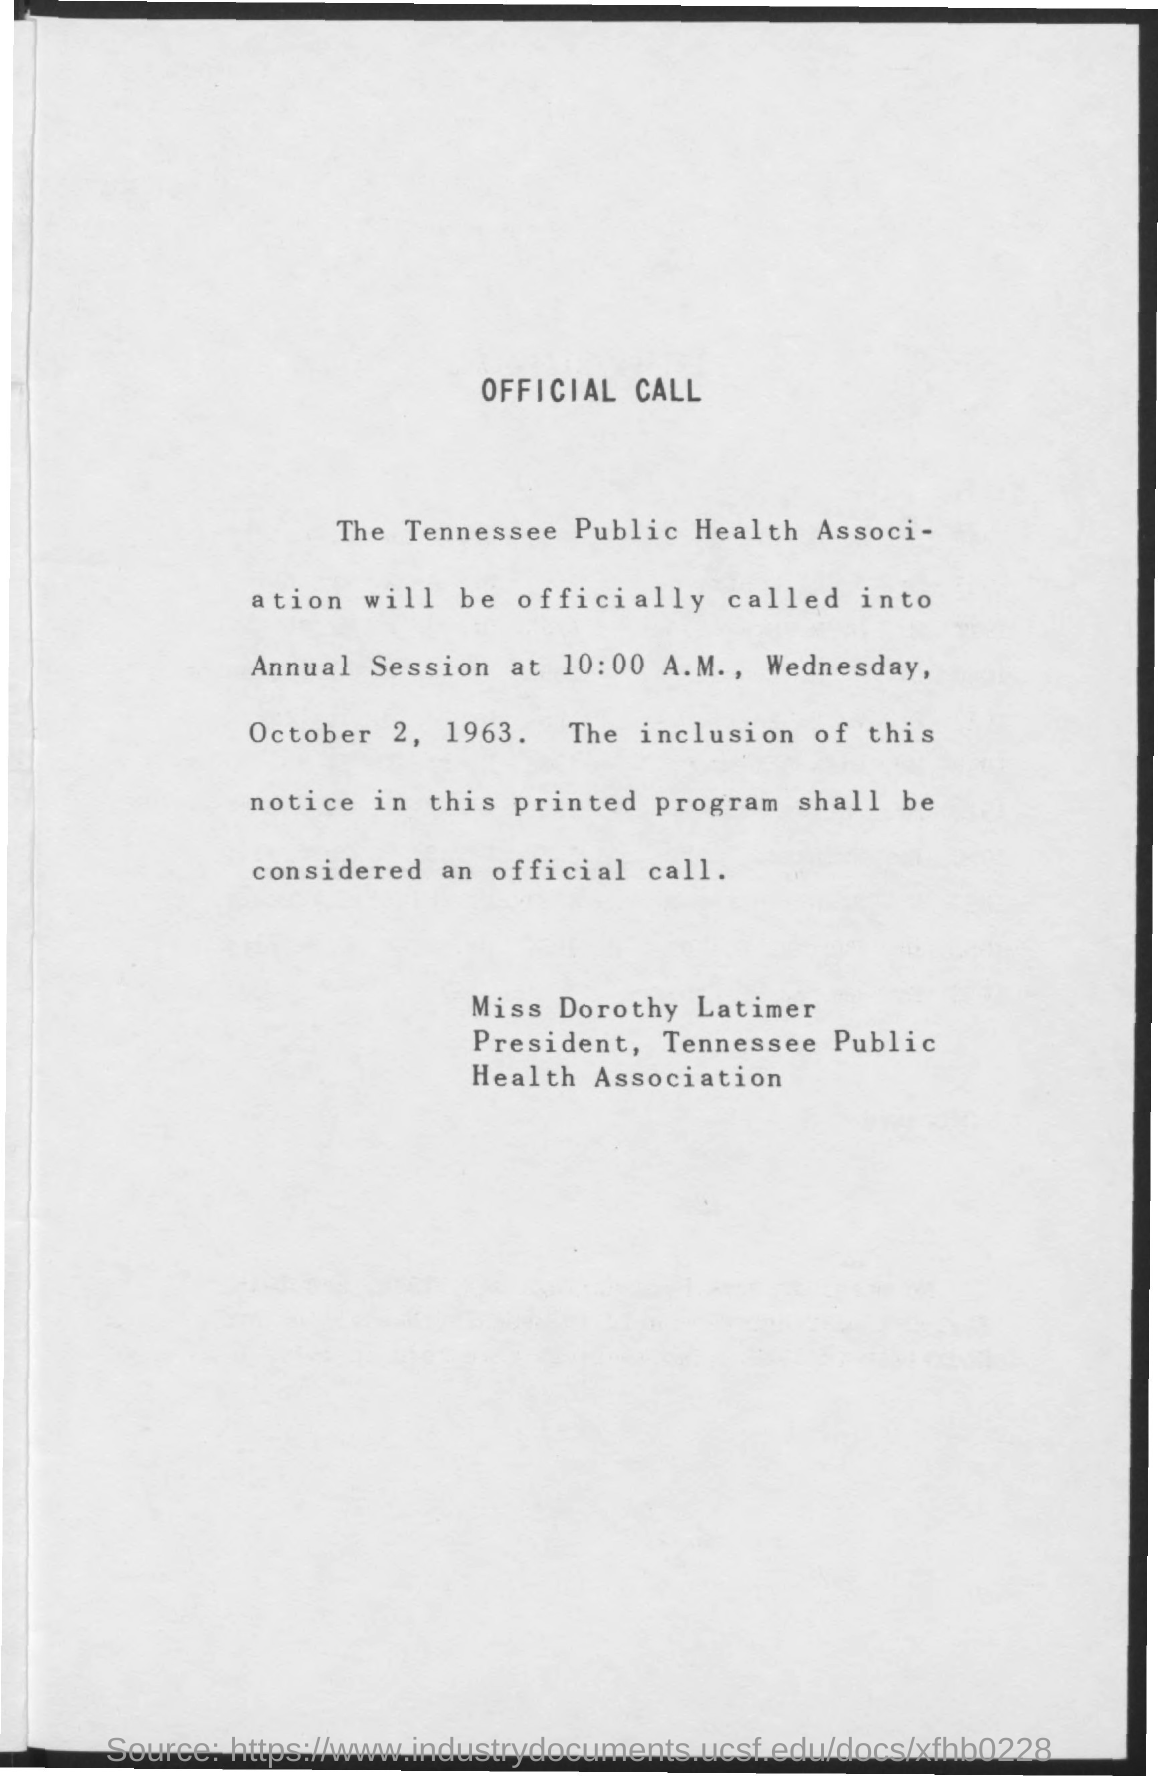Identify some key points in this picture. The Tennessee Public Health Association will officially commence its annual session on Wednesday, October 2, 1963. The Tennessee Public Health Association will be officially called into its annual session at 10:00 a.m. on [date]. 